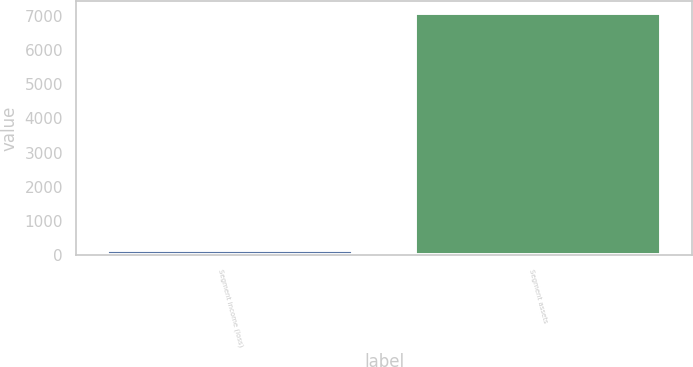Convert chart to OTSL. <chart><loc_0><loc_0><loc_500><loc_500><bar_chart><fcel>Segment income (loss)<fcel>Segment assets<nl><fcel>149<fcel>7097<nl></chart> 